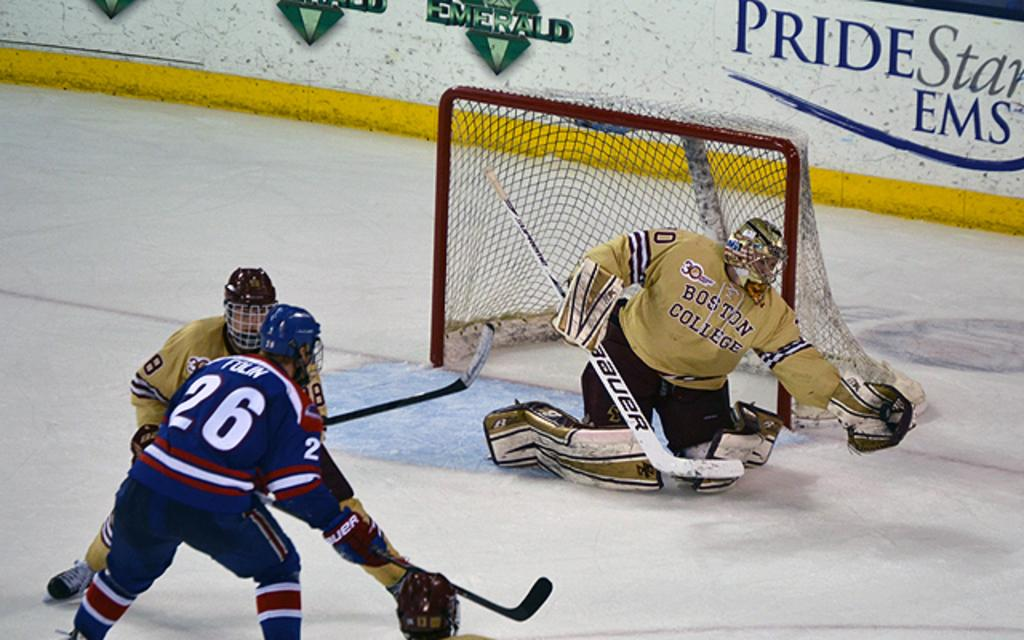What are the people in the foreground of the image doing? The people appear to be playing hockey. What object is associated with the game of hockey in the image? There is a net in the image. What can be seen in the background of the image? There is a wall in the background of the image. What type of process does the farmer use to tend to the queen's garden in the image? There is no farmer or queen present in the image, and therefore no gardening process can be observed. 